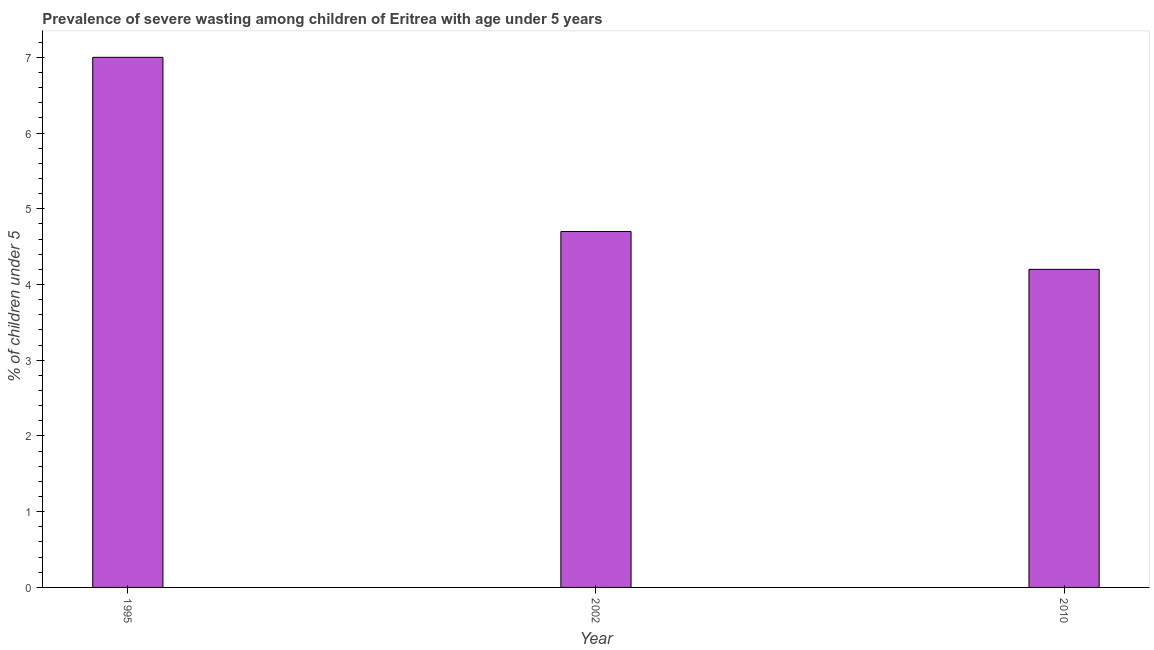Does the graph contain grids?
Your answer should be very brief. No. What is the title of the graph?
Your answer should be very brief. Prevalence of severe wasting among children of Eritrea with age under 5 years. What is the label or title of the X-axis?
Your answer should be very brief. Year. What is the label or title of the Y-axis?
Offer a very short reply.  % of children under 5. What is the prevalence of severe wasting in 2010?
Ensure brevity in your answer.  4.2. Across all years, what is the maximum prevalence of severe wasting?
Your answer should be compact. 7. Across all years, what is the minimum prevalence of severe wasting?
Ensure brevity in your answer.  4.2. What is the sum of the prevalence of severe wasting?
Give a very brief answer. 15.9. What is the difference between the prevalence of severe wasting in 1995 and 2010?
Keep it short and to the point. 2.8. What is the median prevalence of severe wasting?
Provide a short and direct response. 4.7. What is the ratio of the prevalence of severe wasting in 2002 to that in 2010?
Offer a terse response. 1.12. Is the prevalence of severe wasting in 1995 less than that in 2002?
Your answer should be very brief. No. Is the difference between the prevalence of severe wasting in 1995 and 2010 greater than the difference between any two years?
Provide a succinct answer. Yes. What is the difference between the highest and the second highest prevalence of severe wasting?
Your response must be concise. 2.3. Is the sum of the prevalence of severe wasting in 2002 and 2010 greater than the maximum prevalence of severe wasting across all years?
Your response must be concise. Yes. In how many years, is the prevalence of severe wasting greater than the average prevalence of severe wasting taken over all years?
Give a very brief answer. 1. How many bars are there?
Provide a short and direct response. 3. How many years are there in the graph?
Your answer should be compact. 3. What is the  % of children under 5 of 1995?
Offer a very short reply. 7. What is the  % of children under 5 of 2002?
Your answer should be compact. 4.7. What is the  % of children under 5 of 2010?
Offer a very short reply. 4.2. What is the difference between the  % of children under 5 in 1995 and 2002?
Provide a succinct answer. 2.3. What is the difference between the  % of children under 5 in 2002 and 2010?
Your answer should be very brief. 0.5. What is the ratio of the  % of children under 5 in 1995 to that in 2002?
Offer a terse response. 1.49. What is the ratio of the  % of children under 5 in 1995 to that in 2010?
Give a very brief answer. 1.67. What is the ratio of the  % of children under 5 in 2002 to that in 2010?
Your answer should be compact. 1.12. 